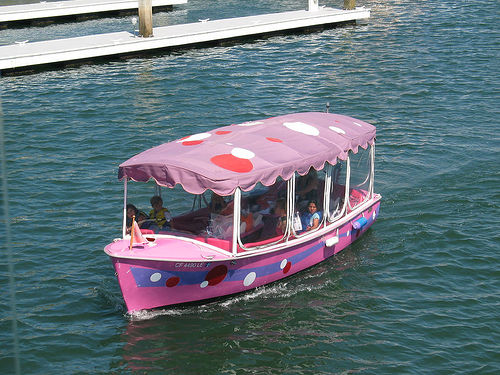Is the clarity of the image above average? Based on the visual information available, the image appears to be of above-average clarity. The details such as the pattern on the boat and the expressions of the people are quite discernible, indicating a clear and high-resolution capture. This suggests that the image quality is indeed better than average. 